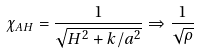Convert formula to latex. <formula><loc_0><loc_0><loc_500><loc_500>\chi _ { A H } = \frac { 1 } { \sqrt { H ^ { 2 } + k / a ^ { 2 } } } \Rightarrow \frac { 1 } { \sqrt { \rho } }</formula> 